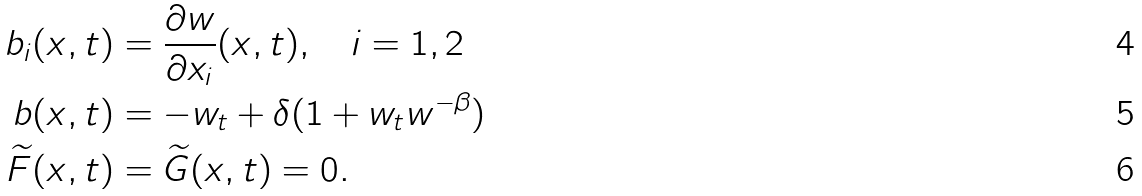<formula> <loc_0><loc_0><loc_500><loc_500>b _ { i } ( x , t ) & = \frac { \partial w } { \partial x _ { i } } ( x , t ) , \quad i = 1 , 2 \\ b ( x , t ) & = - w _ { t } + \delta ( 1 + w _ { t } w ^ { - \beta } ) \\ \widetilde { F } ( x , t ) & = \widetilde { G } ( x , t ) = 0 .</formula> 